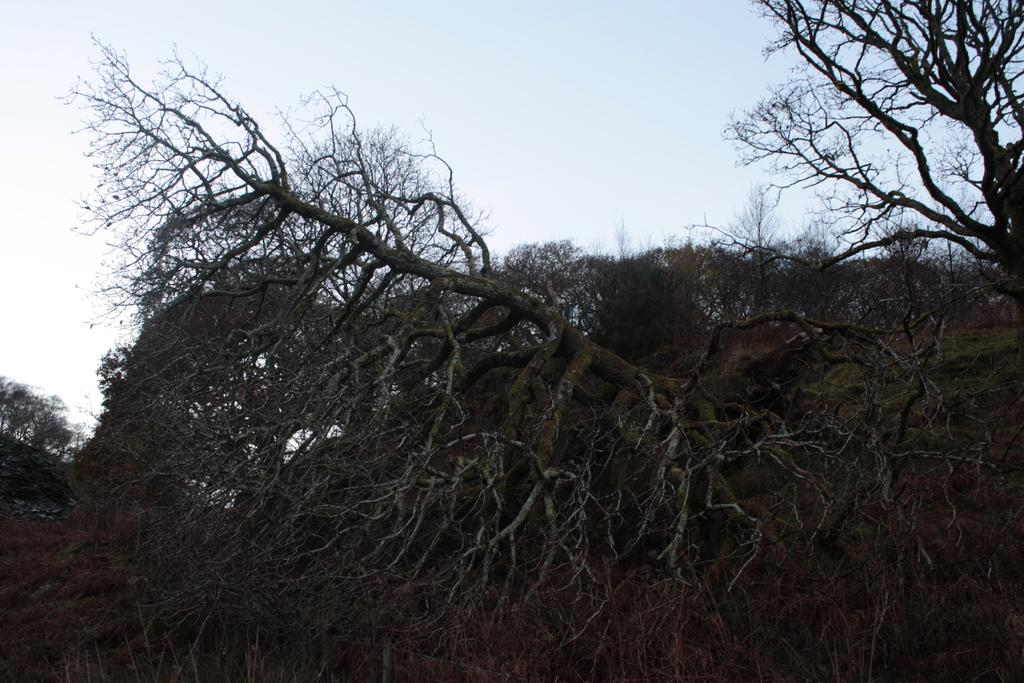What is the primary feature of the image? There are a lot of trees in the image. Can you describe the landscape in the image? The landscape is dominated by trees. Are there any other elements visible in the image besides the trees? The provided facts do not mention any other elements, so we cannot definitively answer this question. What type of bells can be heard ringing in the image? There are no bells present in the image, so we cannot hear any bells ringing. 